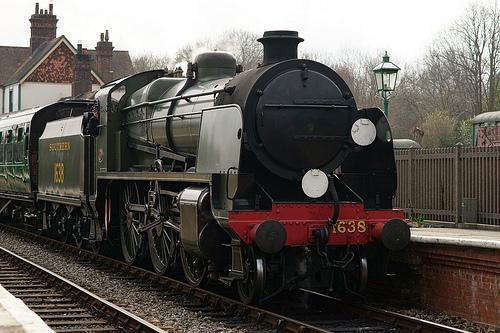How many trains are there?
Give a very brief answer. 1. 